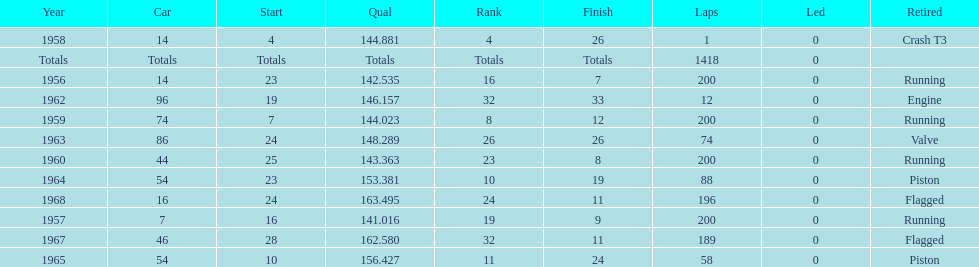Parse the table in full. {'header': ['Year', 'Car', 'Start', 'Qual', 'Rank', 'Finish', 'Laps', 'Led', 'Retired'], 'rows': [['1958', '14', '4', '144.881', '4', '26', '1', '0', 'Crash T3'], ['Totals', 'Totals', 'Totals', 'Totals', 'Totals', 'Totals', '1418', '0', ''], ['1956', '14', '23', '142.535', '16', '7', '200', '0', 'Running'], ['1962', '96', '19', '146.157', '32', '33', '12', '0', 'Engine'], ['1959', '74', '7', '144.023', '8', '12', '200', '0', 'Running'], ['1963', '86', '24', '148.289', '26', '26', '74', '0', 'Valve'], ['1960', '44', '25', '143.363', '23', '8', '200', '0', 'Running'], ['1964', '54', '23', '153.381', '10', '19', '88', '0', 'Piston'], ['1968', '16', '24', '163.495', '24', '11', '196', '0', 'Flagged'], ['1957', '7', '16', '141.016', '19', '9', '200', '0', 'Running'], ['1967', '46', '28', '162.580', '32', '11', '189', '0', 'Flagged'], ['1965', '54', '10', '156.427', '11', '24', '58', '0', 'Piston']]} How many times did he finish all 200 laps? 4. 